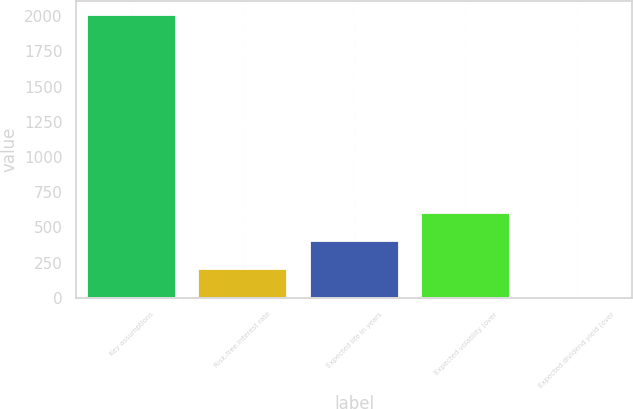Convert chart. <chart><loc_0><loc_0><loc_500><loc_500><bar_chart><fcel>Key assumptions<fcel>Risk-free interest rate<fcel>Expected life in years<fcel>Expected volatility (over<fcel>Expected dividend yield (over<nl><fcel>2005<fcel>203.47<fcel>403.64<fcel>603.81<fcel>3.3<nl></chart> 